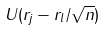Convert formula to latex. <formula><loc_0><loc_0><loc_500><loc_500>U ( r _ { j } - r _ { l } / \sqrt { n } )</formula> 